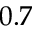<formula> <loc_0><loc_0><loc_500><loc_500>0 . 7</formula> 